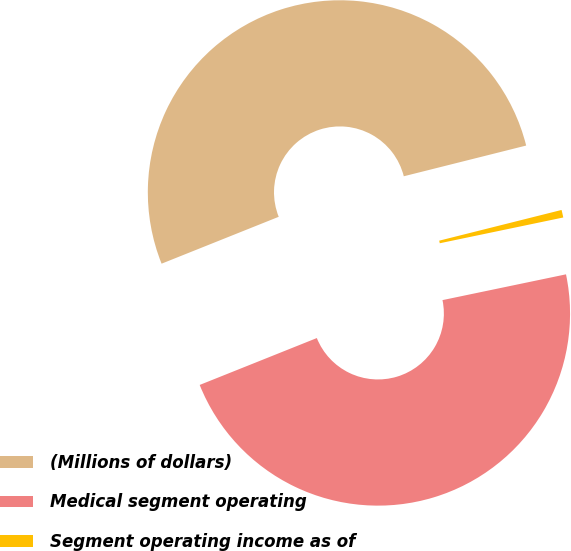<chart> <loc_0><loc_0><loc_500><loc_500><pie_chart><fcel>(Millions of dollars)<fcel>Medical segment operating<fcel>Segment operating income as of<nl><fcel>52.15%<fcel>47.22%<fcel>0.64%<nl></chart> 